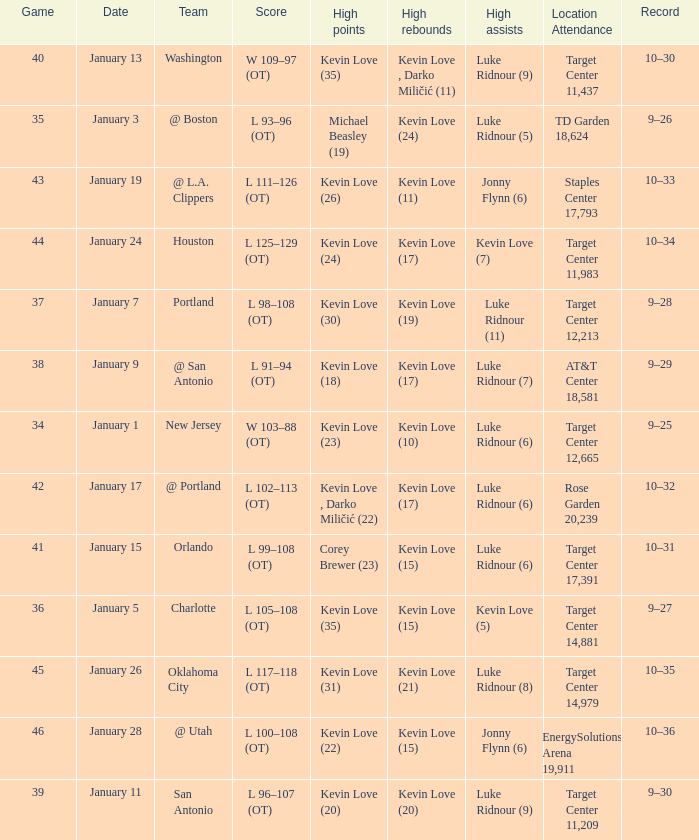Who had the high points when the team was charlotte? Kevin Love (35). 